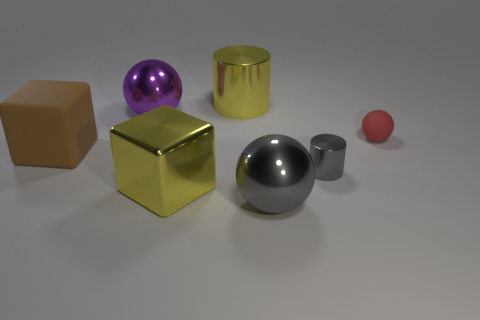Subtract all purple spheres. How many spheres are left? 2 Subtract all yellow cylinders. How many cylinders are left? 1 Subtract all cylinders. How many objects are left? 5 Subtract 1 spheres. How many spheres are left? 2 Add 6 brown blocks. How many brown blocks are left? 7 Add 4 big blue things. How many big blue things exist? 4 Add 3 tiny rubber spheres. How many objects exist? 10 Subtract 0 cyan cubes. How many objects are left? 7 Subtract all purple cylinders. Subtract all green spheres. How many cylinders are left? 2 Subtract all rubber objects. Subtract all metal cylinders. How many objects are left? 3 